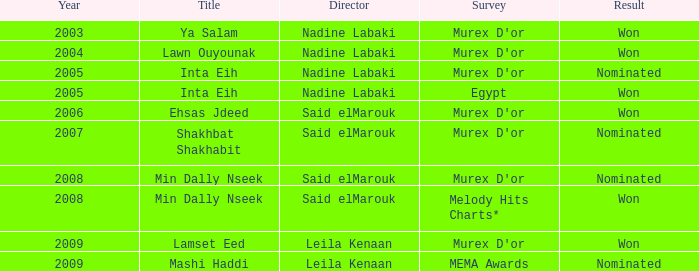What is the title for the Murex D'or survey, after 2005, Said Elmarouk as director, and was nominated? Shakhbat Shakhabit, Min Dally Nseek. 